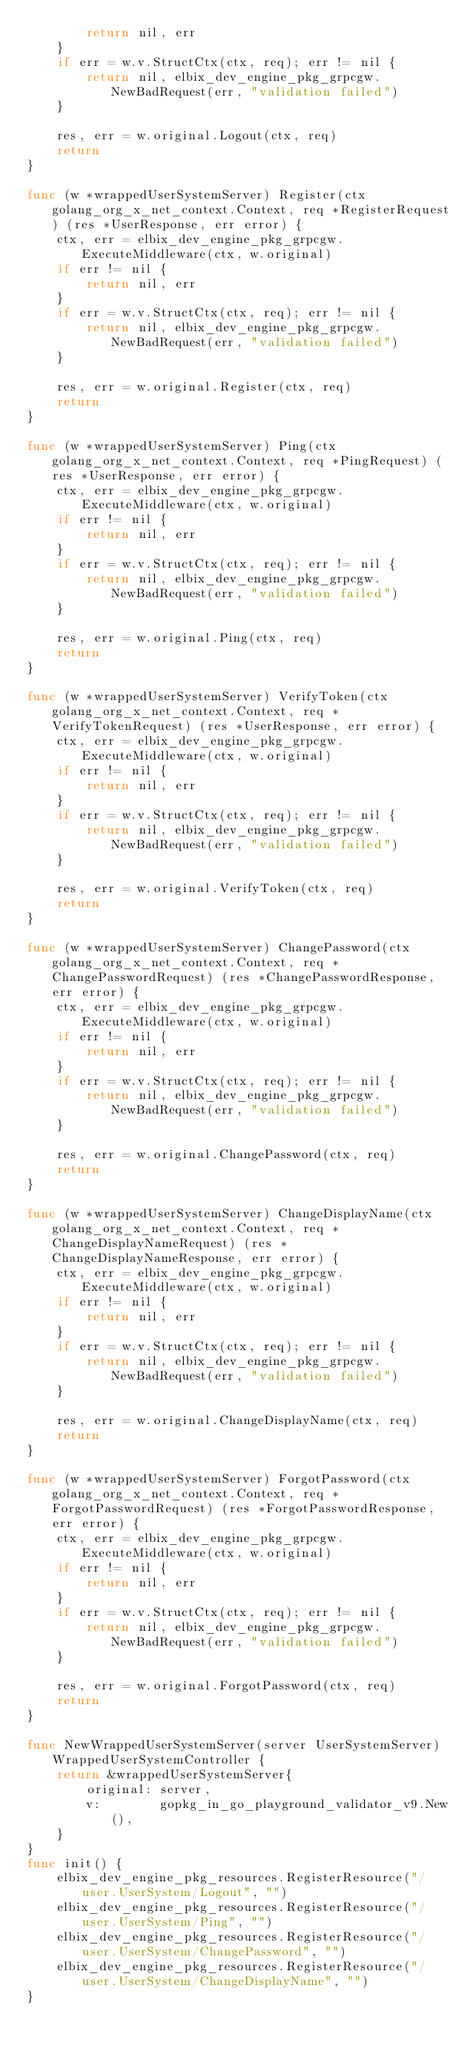Convert code to text. <code><loc_0><loc_0><loc_500><loc_500><_Go_>		return nil, err
	}
	if err = w.v.StructCtx(ctx, req); err != nil {
		return nil, elbix_dev_engine_pkg_grpcgw.NewBadRequest(err, "validation failed")
	}

	res, err = w.original.Logout(ctx, req)
	return
}

func (w *wrappedUserSystemServer) Register(ctx golang_org_x_net_context.Context, req *RegisterRequest) (res *UserResponse, err error) {
	ctx, err = elbix_dev_engine_pkg_grpcgw.ExecuteMiddleware(ctx, w.original)
	if err != nil {
		return nil, err
	}
	if err = w.v.StructCtx(ctx, req); err != nil {
		return nil, elbix_dev_engine_pkg_grpcgw.NewBadRequest(err, "validation failed")
	}

	res, err = w.original.Register(ctx, req)
	return
}

func (w *wrappedUserSystemServer) Ping(ctx golang_org_x_net_context.Context, req *PingRequest) (res *UserResponse, err error) {
	ctx, err = elbix_dev_engine_pkg_grpcgw.ExecuteMiddleware(ctx, w.original)
	if err != nil {
		return nil, err
	}
	if err = w.v.StructCtx(ctx, req); err != nil {
		return nil, elbix_dev_engine_pkg_grpcgw.NewBadRequest(err, "validation failed")
	}

	res, err = w.original.Ping(ctx, req)
	return
}

func (w *wrappedUserSystemServer) VerifyToken(ctx golang_org_x_net_context.Context, req *VerifyTokenRequest) (res *UserResponse, err error) {
	ctx, err = elbix_dev_engine_pkg_grpcgw.ExecuteMiddleware(ctx, w.original)
	if err != nil {
		return nil, err
	}
	if err = w.v.StructCtx(ctx, req); err != nil {
		return nil, elbix_dev_engine_pkg_grpcgw.NewBadRequest(err, "validation failed")
	}

	res, err = w.original.VerifyToken(ctx, req)
	return
}

func (w *wrappedUserSystemServer) ChangePassword(ctx golang_org_x_net_context.Context, req *ChangePasswordRequest) (res *ChangePasswordResponse, err error) {
	ctx, err = elbix_dev_engine_pkg_grpcgw.ExecuteMiddleware(ctx, w.original)
	if err != nil {
		return nil, err
	}
	if err = w.v.StructCtx(ctx, req); err != nil {
		return nil, elbix_dev_engine_pkg_grpcgw.NewBadRequest(err, "validation failed")
	}

	res, err = w.original.ChangePassword(ctx, req)
	return
}

func (w *wrappedUserSystemServer) ChangeDisplayName(ctx golang_org_x_net_context.Context, req *ChangeDisplayNameRequest) (res *ChangeDisplayNameResponse, err error) {
	ctx, err = elbix_dev_engine_pkg_grpcgw.ExecuteMiddleware(ctx, w.original)
	if err != nil {
		return nil, err
	}
	if err = w.v.StructCtx(ctx, req); err != nil {
		return nil, elbix_dev_engine_pkg_grpcgw.NewBadRequest(err, "validation failed")
	}

	res, err = w.original.ChangeDisplayName(ctx, req)
	return
}

func (w *wrappedUserSystemServer) ForgotPassword(ctx golang_org_x_net_context.Context, req *ForgotPasswordRequest) (res *ForgotPasswordResponse, err error) {
	ctx, err = elbix_dev_engine_pkg_grpcgw.ExecuteMiddleware(ctx, w.original)
	if err != nil {
		return nil, err
	}
	if err = w.v.StructCtx(ctx, req); err != nil {
		return nil, elbix_dev_engine_pkg_grpcgw.NewBadRequest(err, "validation failed")
	}

	res, err = w.original.ForgotPassword(ctx, req)
	return
}

func NewWrappedUserSystemServer(server UserSystemServer) WrappedUserSystemController {
	return &wrappedUserSystemServer{
		original: server,
		v:        gopkg_in_go_playground_validator_v9.New(),
	}
}
func init() {
	elbix_dev_engine_pkg_resources.RegisterResource("/user.UserSystem/Logout", "")
	elbix_dev_engine_pkg_resources.RegisterResource("/user.UserSystem/Ping", "")
	elbix_dev_engine_pkg_resources.RegisterResource("/user.UserSystem/ChangePassword", "")
	elbix_dev_engine_pkg_resources.RegisterResource("/user.UserSystem/ChangeDisplayName", "")
}
</code> 